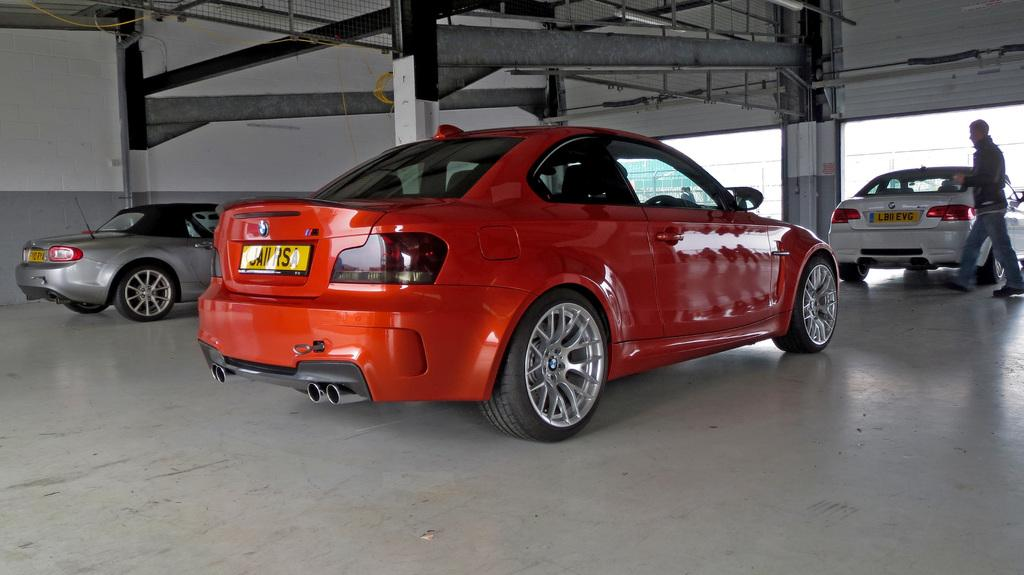What is happening on the path in the image? There are vehicles parked on the path in the image. What is the person in the image doing? A person is walking in the image. What architectural features can be seen behind the vehicles? There are pillars and a wall visible behind the vehicles. What can be seen in the background of the image? The sky is visible in the image. How many pins are holding the vehicles in place in the image? There are no pins visible in the image, and the vehicles are parked, not held in place by pins. What type of match is being played in the image? There is no match being played in the image; it features parked vehicles and a person walking. 